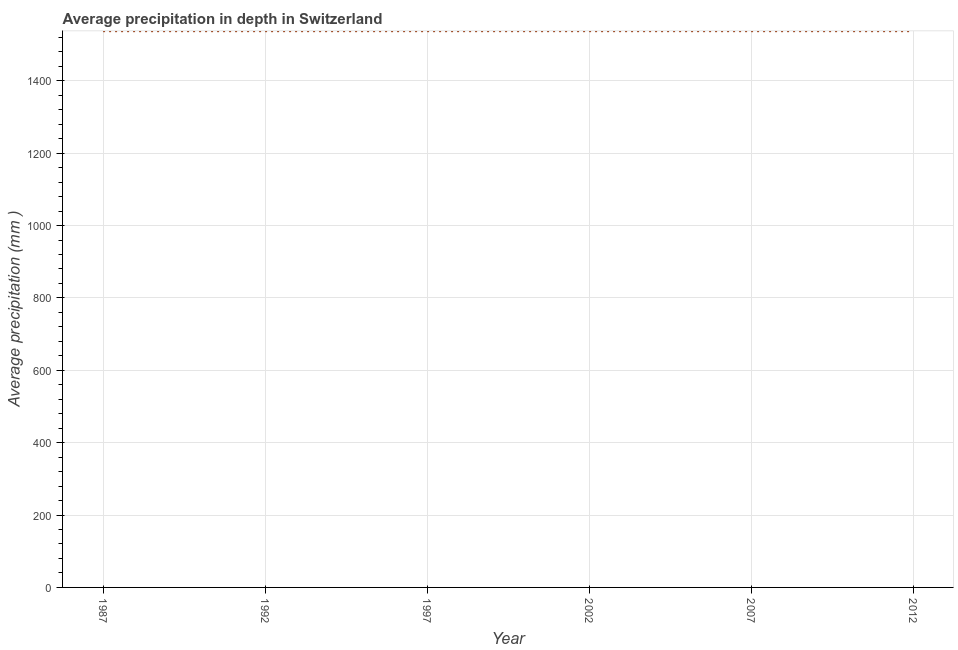What is the average precipitation in depth in 1992?
Provide a short and direct response. 1537. Across all years, what is the maximum average precipitation in depth?
Offer a very short reply. 1537. Across all years, what is the minimum average precipitation in depth?
Keep it short and to the point. 1537. In which year was the average precipitation in depth minimum?
Make the answer very short. 1987. What is the sum of the average precipitation in depth?
Your answer should be compact. 9222. What is the difference between the average precipitation in depth in 1997 and 2012?
Offer a terse response. 0. What is the average average precipitation in depth per year?
Ensure brevity in your answer.  1537. What is the median average precipitation in depth?
Keep it short and to the point. 1537. In how many years, is the average precipitation in depth greater than 120 mm?
Offer a terse response. 6. Do a majority of the years between 2007 and 1992 (inclusive) have average precipitation in depth greater than 480 mm?
Offer a very short reply. Yes. What is the ratio of the average precipitation in depth in 1987 to that in 1992?
Your answer should be very brief. 1. What is the difference between the highest and the lowest average precipitation in depth?
Offer a very short reply. 0. In how many years, is the average precipitation in depth greater than the average average precipitation in depth taken over all years?
Give a very brief answer. 0. What is the difference between two consecutive major ticks on the Y-axis?
Your response must be concise. 200. Does the graph contain any zero values?
Your response must be concise. No. What is the title of the graph?
Your answer should be compact. Average precipitation in depth in Switzerland. What is the label or title of the X-axis?
Offer a terse response. Year. What is the label or title of the Y-axis?
Offer a very short reply. Average precipitation (mm ). What is the Average precipitation (mm ) in 1987?
Offer a very short reply. 1537. What is the Average precipitation (mm ) in 1992?
Provide a short and direct response. 1537. What is the Average precipitation (mm ) in 1997?
Make the answer very short. 1537. What is the Average precipitation (mm ) of 2002?
Your answer should be very brief. 1537. What is the Average precipitation (mm ) of 2007?
Give a very brief answer. 1537. What is the Average precipitation (mm ) in 2012?
Provide a succinct answer. 1537. What is the difference between the Average precipitation (mm ) in 1987 and 1992?
Your answer should be very brief. 0. What is the difference between the Average precipitation (mm ) in 1987 and 2012?
Keep it short and to the point. 0. What is the difference between the Average precipitation (mm ) in 1992 and 1997?
Your answer should be very brief. 0. What is the difference between the Average precipitation (mm ) in 1997 and 2002?
Provide a succinct answer. 0. What is the difference between the Average precipitation (mm ) in 1997 and 2007?
Provide a short and direct response. 0. What is the difference between the Average precipitation (mm ) in 2002 and 2007?
Your answer should be very brief. 0. What is the difference between the Average precipitation (mm ) in 2002 and 2012?
Keep it short and to the point. 0. What is the ratio of the Average precipitation (mm ) in 1987 to that in 1992?
Provide a succinct answer. 1. What is the ratio of the Average precipitation (mm ) in 1987 to that in 2002?
Your answer should be compact. 1. What is the ratio of the Average precipitation (mm ) in 1997 to that in 2002?
Make the answer very short. 1. 